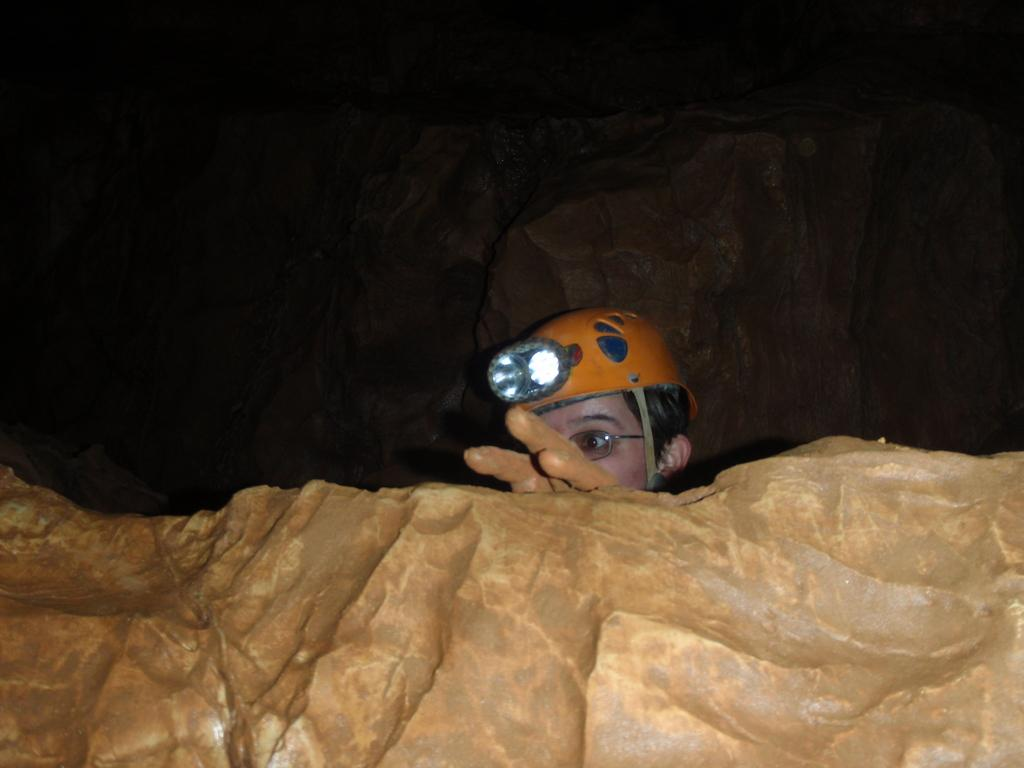What is the main object in the image? There is a rock in the image. Who or what else is present in the image? There is a person in the image. Can you describe the person's appearance? The person is wearing spectacles and a helmet with a light. What can be seen in the background of the image? There are rocks visible behind the person. What is the aftermath of the person's act of balancing on the rock in the image? There is no act of balancing or aftermath mentioned in the image; it only shows a person wearing a helmet with a light and spectacles standing near a rock. 